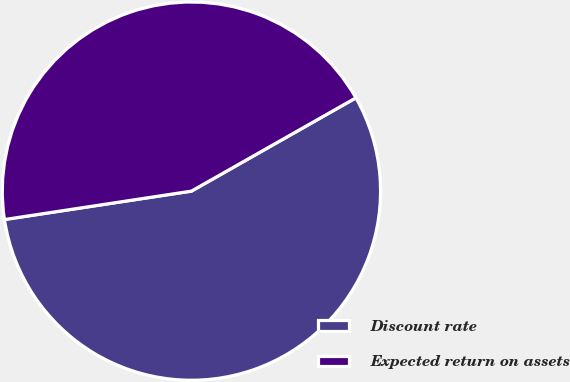Convert chart to OTSL. <chart><loc_0><loc_0><loc_500><loc_500><pie_chart><fcel>Discount rate<fcel>Expected return on assets<nl><fcel>55.81%<fcel>44.19%<nl></chart> 